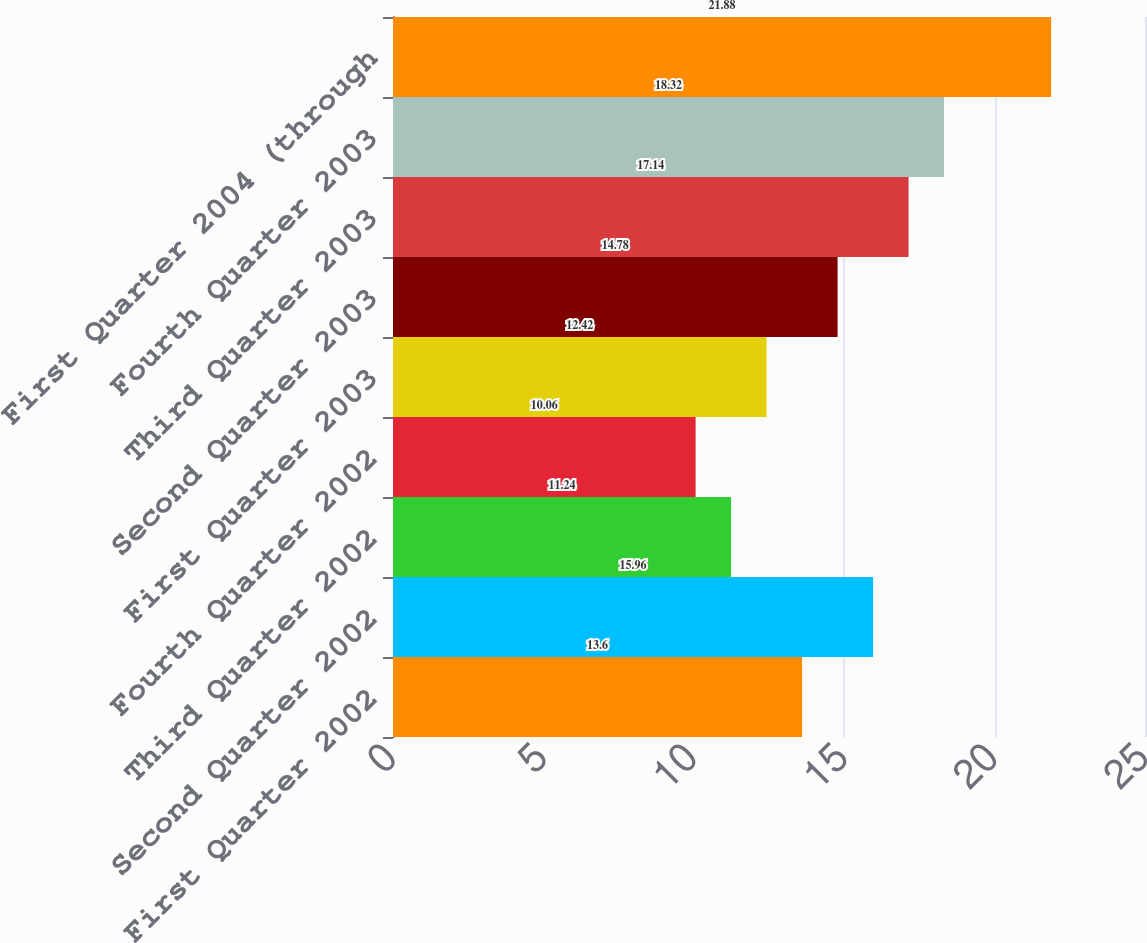<chart> <loc_0><loc_0><loc_500><loc_500><bar_chart><fcel>First Quarter 2002<fcel>Second Quarter 2002<fcel>Third Quarter 2002<fcel>Fourth Quarter 2002<fcel>First Quarter 2003<fcel>Second Quarter 2003<fcel>Third Quarter 2003<fcel>Fourth Quarter 2003<fcel>First Quarter 2004 (through<nl><fcel>13.6<fcel>15.96<fcel>11.24<fcel>10.06<fcel>12.42<fcel>14.78<fcel>17.14<fcel>18.32<fcel>21.88<nl></chart> 